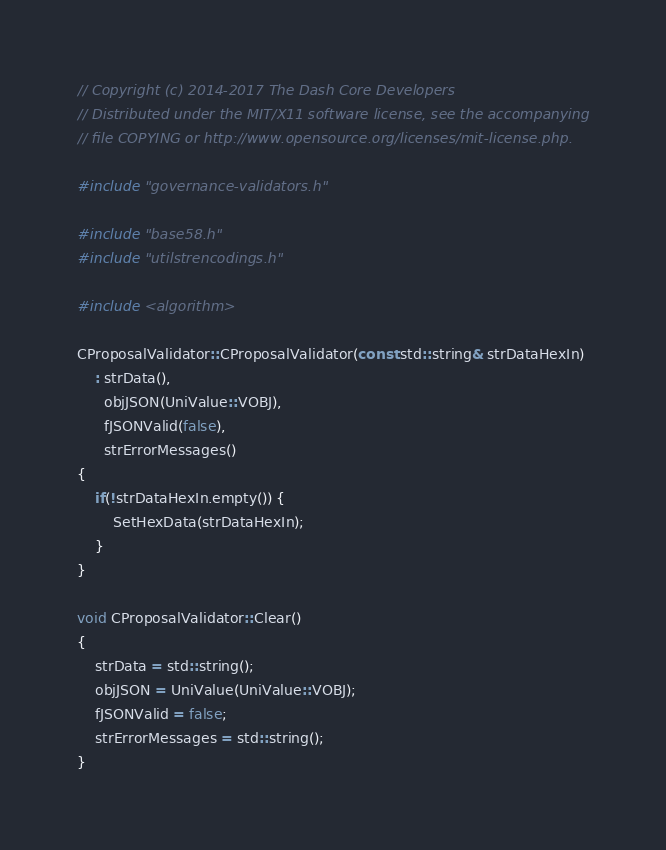Convert code to text. <code><loc_0><loc_0><loc_500><loc_500><_C++_>// Copyright (c) 2014-2017 The Dash Core Developers
// Distributed under the MIT/X11 software license, see the accompanying
// file COPYING or http://www.opensource.org/licenses/mit-license.php.

#include "governance-validators.h"

#include "base58.h"
#include "utilstrencodings.h"

#include <algorithm>

CProposalValidator::CProposalValidator(const std::string& strDataHexIn)
    : strData(),
      objJSON(UniValue::VOBJ),
      fJSONValid(false),
      strErrorMessages()
{
    if(!strDataHexIn.empty()) {
        SetHexData(strDataHexIn);
    }
}

void CProposalValidator::Clear()
{
    strData = std::string();
    objJSON = UniValue(UniValue::VOBJ);
    fJSONValid = false;
    strErrorMessages = std::string();
}
</code> 